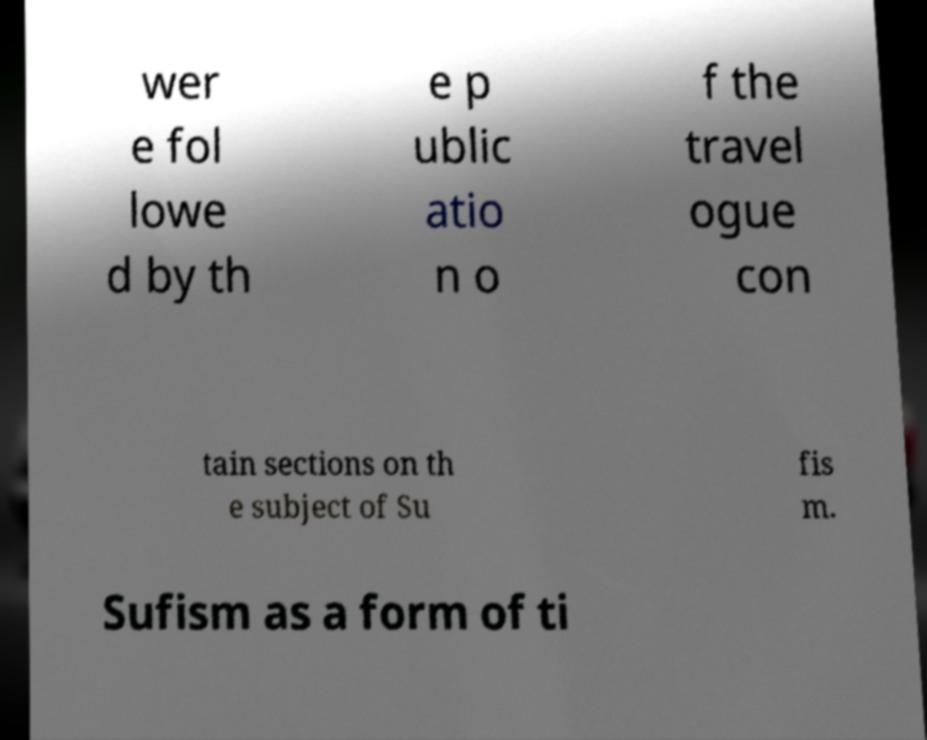For documentation purposes, I need the text within this image transcribed. Could you provide that? wer e fol lowe d by th e p ublic atio n o f the travel ogue con tain sections on th e subject of Su fis m. Sufism as a form of ti 